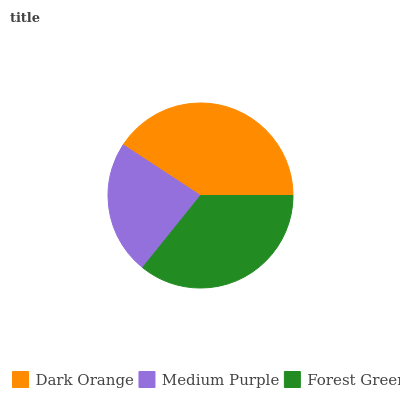Is Medium Purple the minimum?
Answer yes or no. Yes. Is Dark Orange the maximum?
Answer yes or no. Yes. Is Forest Green the minimum?
Answer yes or no. No. Is Forest Green the maximum?
Answer yes or no. No. Is Forest Green greater than Medium Purple?
Answer yes or no. Yes. Is Medium Purple less than Forest Green?
Answer yes or no. Yes. Is Medium Purple greater than Forest Green?
Answer yes or no. No. Is Forest Green less than Medium Purple?
Answer yes or no. No. Is Forest Green the high median?
Answer yes or no. Yes. Is Forest Green the low median?
Answer yes or no. Yes. Is Medium Purple the high median?
Answer yes or no. No. Is Dark Orange the low median?
Answer yes or no. No. 